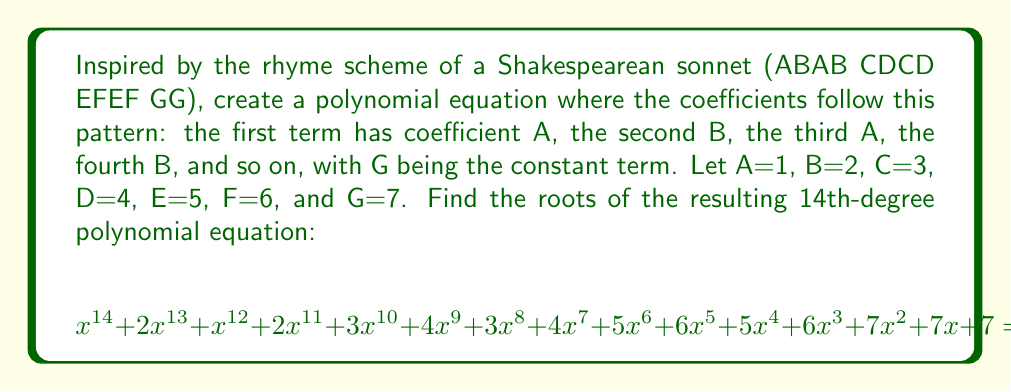Show me your answer to this math problem. To find the roots of this polynomial, we need to factor it. Given the complexity of the equation, we'll use the rational root theorem and synthetic division to find the rational roots, if any exist.

1) First, let's list the possible rational roots using the rational root theorem. The possible roots are the factors of the constant term (7) divided by the factors of the leading coefficient (1):
   $\pm 1, \pm 7$

2) Let's test these potential roots using synthetic division:

   Testing x = 1:
   $$1 | 1 \quad 2 \quad 1 \quad 2 \quad 3 \quad 4 \quad 3 \quad 4 \quad 5 \quad 6 \quad 5 \quad 6 \quad 7 \quad 7 \quad 7$$
   $$\quad\quad 1 \quad 3 \quad 4 \quad 6 \quad 9 \quad 13 \quad 16 \quad 20 \quad 25 \quad 31 \quad 36 \quad 42 \quad 49 \quad 56$$
   $$1 \quad 3 \quad 4 \quad 6 \quad 9 \quad 13 \quad 16 \quad 20 \quad 25 \quad 31 \quad 36 \quad 42 \quad 49 \quad 56 \quad 63$$

   The remainder is 63, so x = 1 is not a root.

   Testing x = -1:
   $$-1 | 1 \quad 2 \quad 1 \quad 2 \quad 3 \quad 4 \quad 3 \quad 4 \quad 5 \quad 6 \quad 5 \quad 6 \quad 7 \quad 7 \quad 7$$
   $$\quad\quad -1 \quad -1 \quad 0 \quad -2 \quad -1 \quad -3 \quad 0 \quad -4 \quad -1 \quad -5 \quad 0 \quad -6 \quad -1 \quad -6$$
   $$1 \quad 1 \quad 0 \quad 2 \quad 1 \quad 3 \quad 0 \quad 4 \quad 1 \quad 5 \quad 0 \quad 6 \quad 1 \quad 6 \quad 1$$

   The remainder is 1, so x = -1 is not a root.

   Testing x = 7 and x = -7 also yields non-zero remainders.

3) Since none of the possible rational roots work, this polynomial has no rational roots.

4) Given that this is a 14th-degree polynomial with no rational roots, finding the exact irrational or complex roots would be extremely difficult without numerical methods.

5) We can conclude that all roots of this polynomial are either irrational or complex numbers.
Answer: The polynomial has no rational roots. All 14 roots are either irrational or complex numbers. 